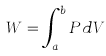<formula> <loc_0><loc_0><loc_500><loc_500>W = \int _ { a } ^ { b } P d V</formula> 